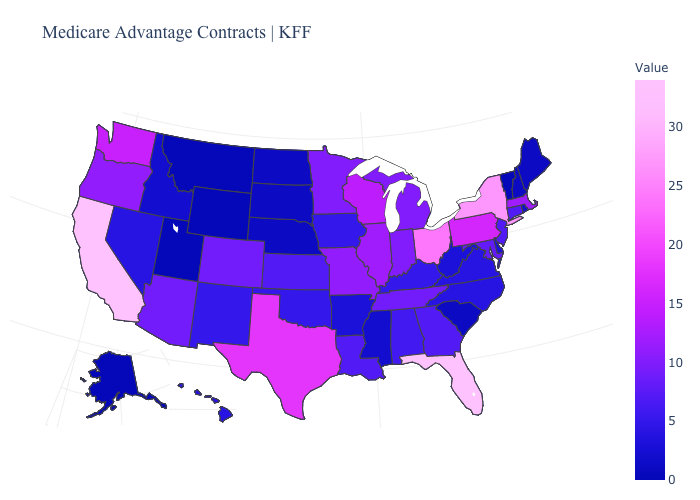Does Florida have the highest value in the USA?
Keep it brief. Yes. Is the legend a continuous bar?
Give a very brief answer. Yes. Does Louisiana have the highest value in the USA?
Quick response, please. No. Does the map have missing data?
Answer briefly. No. 